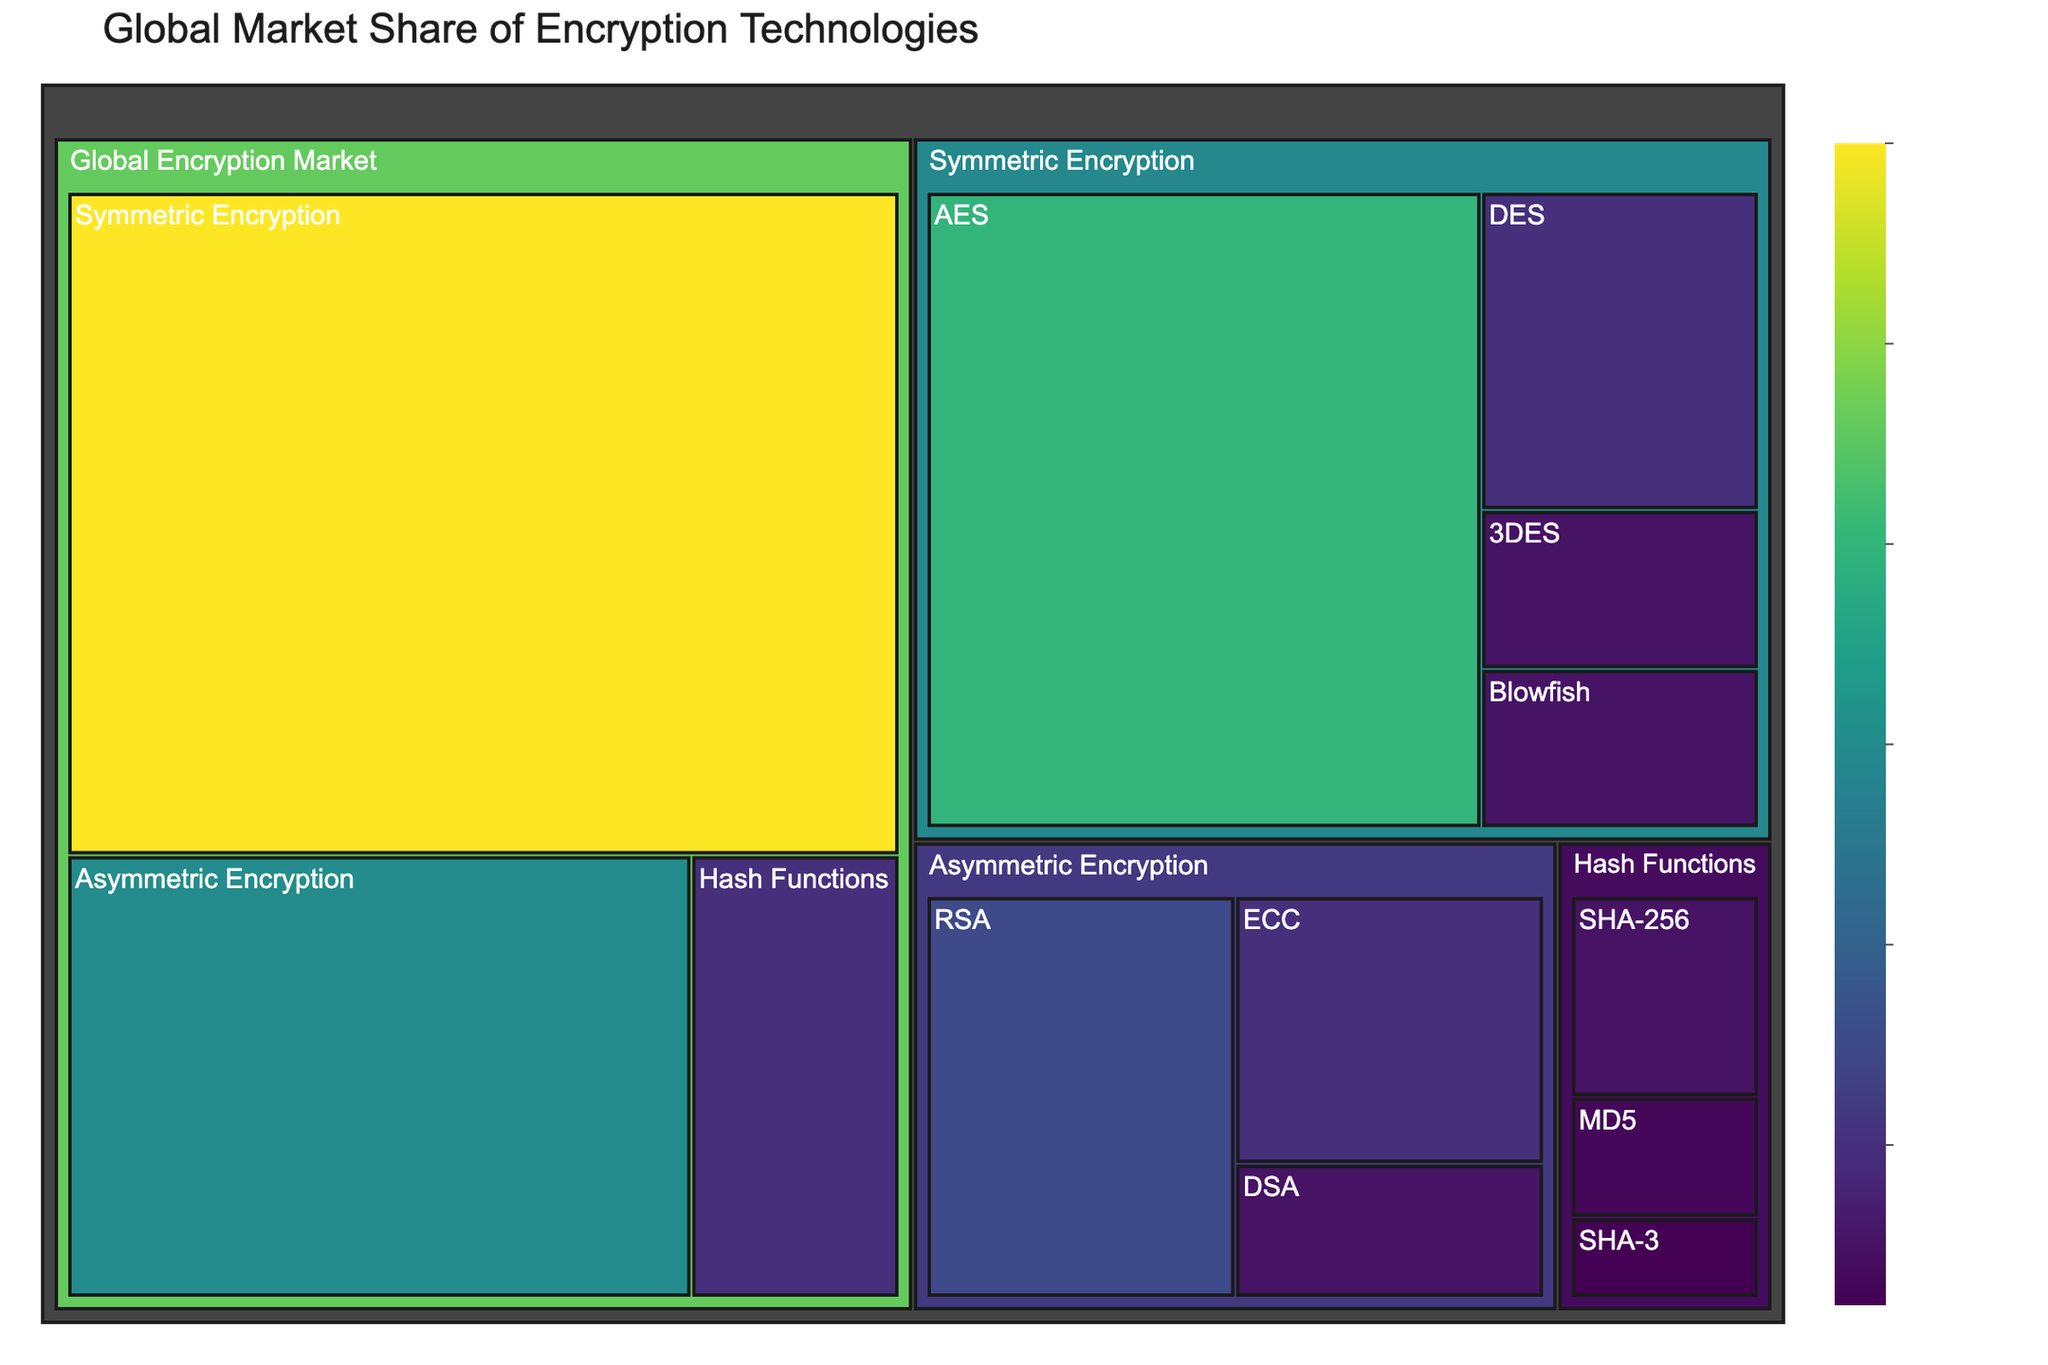what's the title of the figure? The title is usually found at the top of the figure in larger, bolded text.
Answer: Global Market Share of Encryption Technologies Which encryption algorithm has the highest market share? By inspecting the largest section of the treemap, we see the name "AES" which indicates it has the highest market share.
Answer: AES What is the combined market share of DES and 3DES? Locate the sections for DES and 3DES. Add their market shares: 10% (DES) + 5% (3DES) = 15%.
Answer: 15% Which category accounts for the largest portion of the market share? By looking at the largest main section, Symmetric Encryption occupies the largest area, indicating it has the greatest market share.
Answer: Symmetric Encryption How does the market share of RSA compare to ECC? Locate both RSA and ECC on the treemap. RSA's market share is 15%, while ECC's market share is 10%. Compare these two values.
Answer: RSA has a larger market share than ECC How is the market share distributed across Hash Functions? Examine the sections within Hash Functions. SHA-256 has 5%, MD5 has 3%, and SHA-3 has 2%.
Answer: SHA-256: 5%, MD5: 3%, SHA-3: 2% What is the total market share covered by asymmetric encryption algorithms? Add the market shares of RSA (15%), ECC (10%), and DSA (5%): 15% + 10% + 5% = 30%.
Answer: 30% Which symmetric encryption algorithm has the smallest market share? Compare the market shares of all symmetric encryption algorithms: AES, DES, 3DES, Blowfish. Blowfish has the smallest market share of 5%.
Answer: Blowfish How does the market share of SHA-256 compare to MD5? Locate both SHA-256 and MD5 on the treemap. SHA-256's market share is 5%, while MD5's market share is 3%. Compare these values.
Answer: SHA-256 has a larger market share than MD5 What percentage of the global encryption market share is occupied by non-symmetric encryption methods? Sum the market shares of Asymmetric Encryption (30%) and Hash Functions (10%): 30% + 10% = 40%.
Answer: 40% 